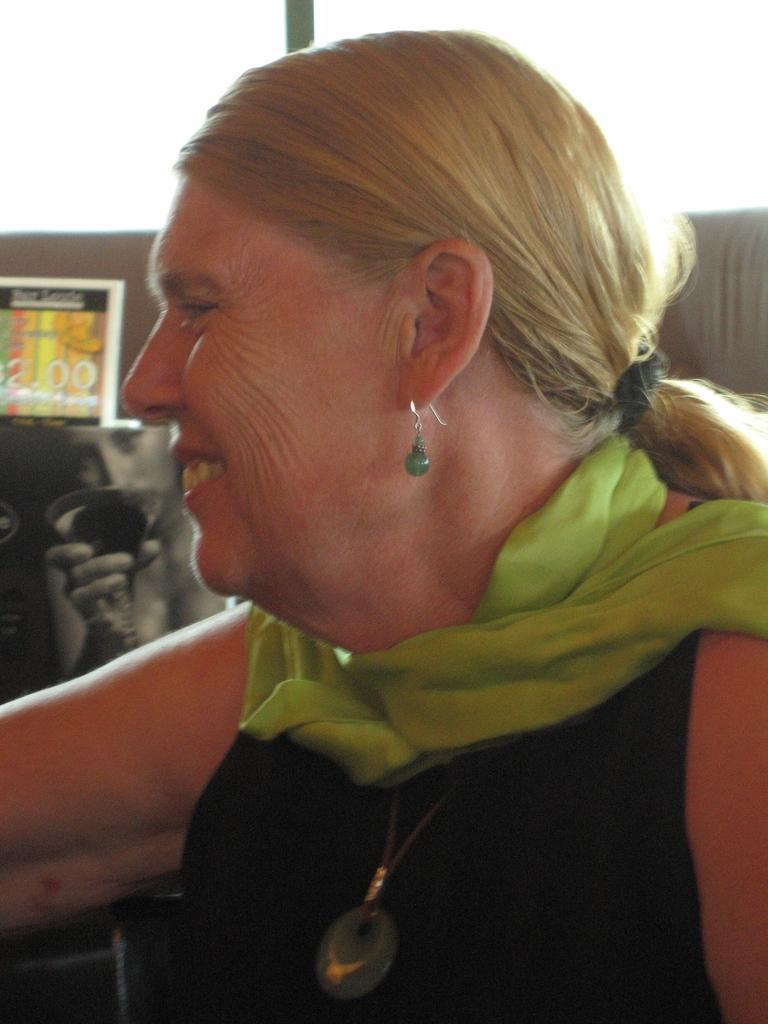Can you describe this image briefly? A woman is present wearing a green stole and a black dress. She is wearing an earring and has blonde hair. 